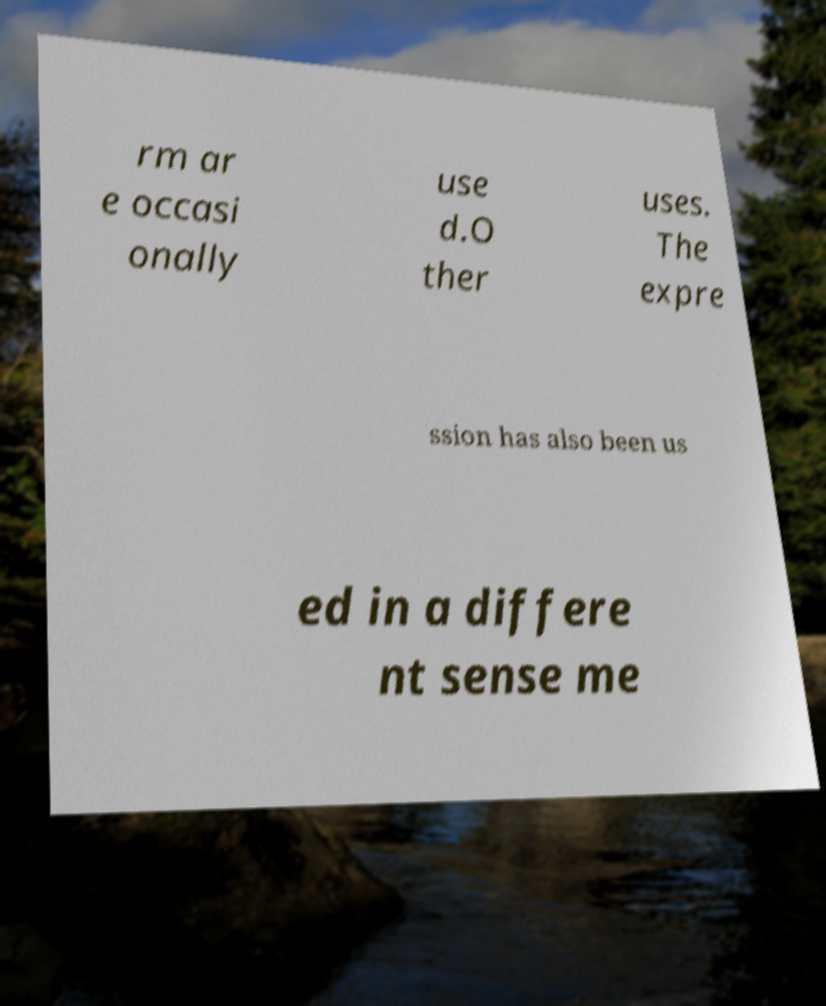Can you accurately transcribe the text from the provided image for me? rm ar e occasi onally use d.O ther uses. The expre ssion has also been us ed in a differe nt sense me 